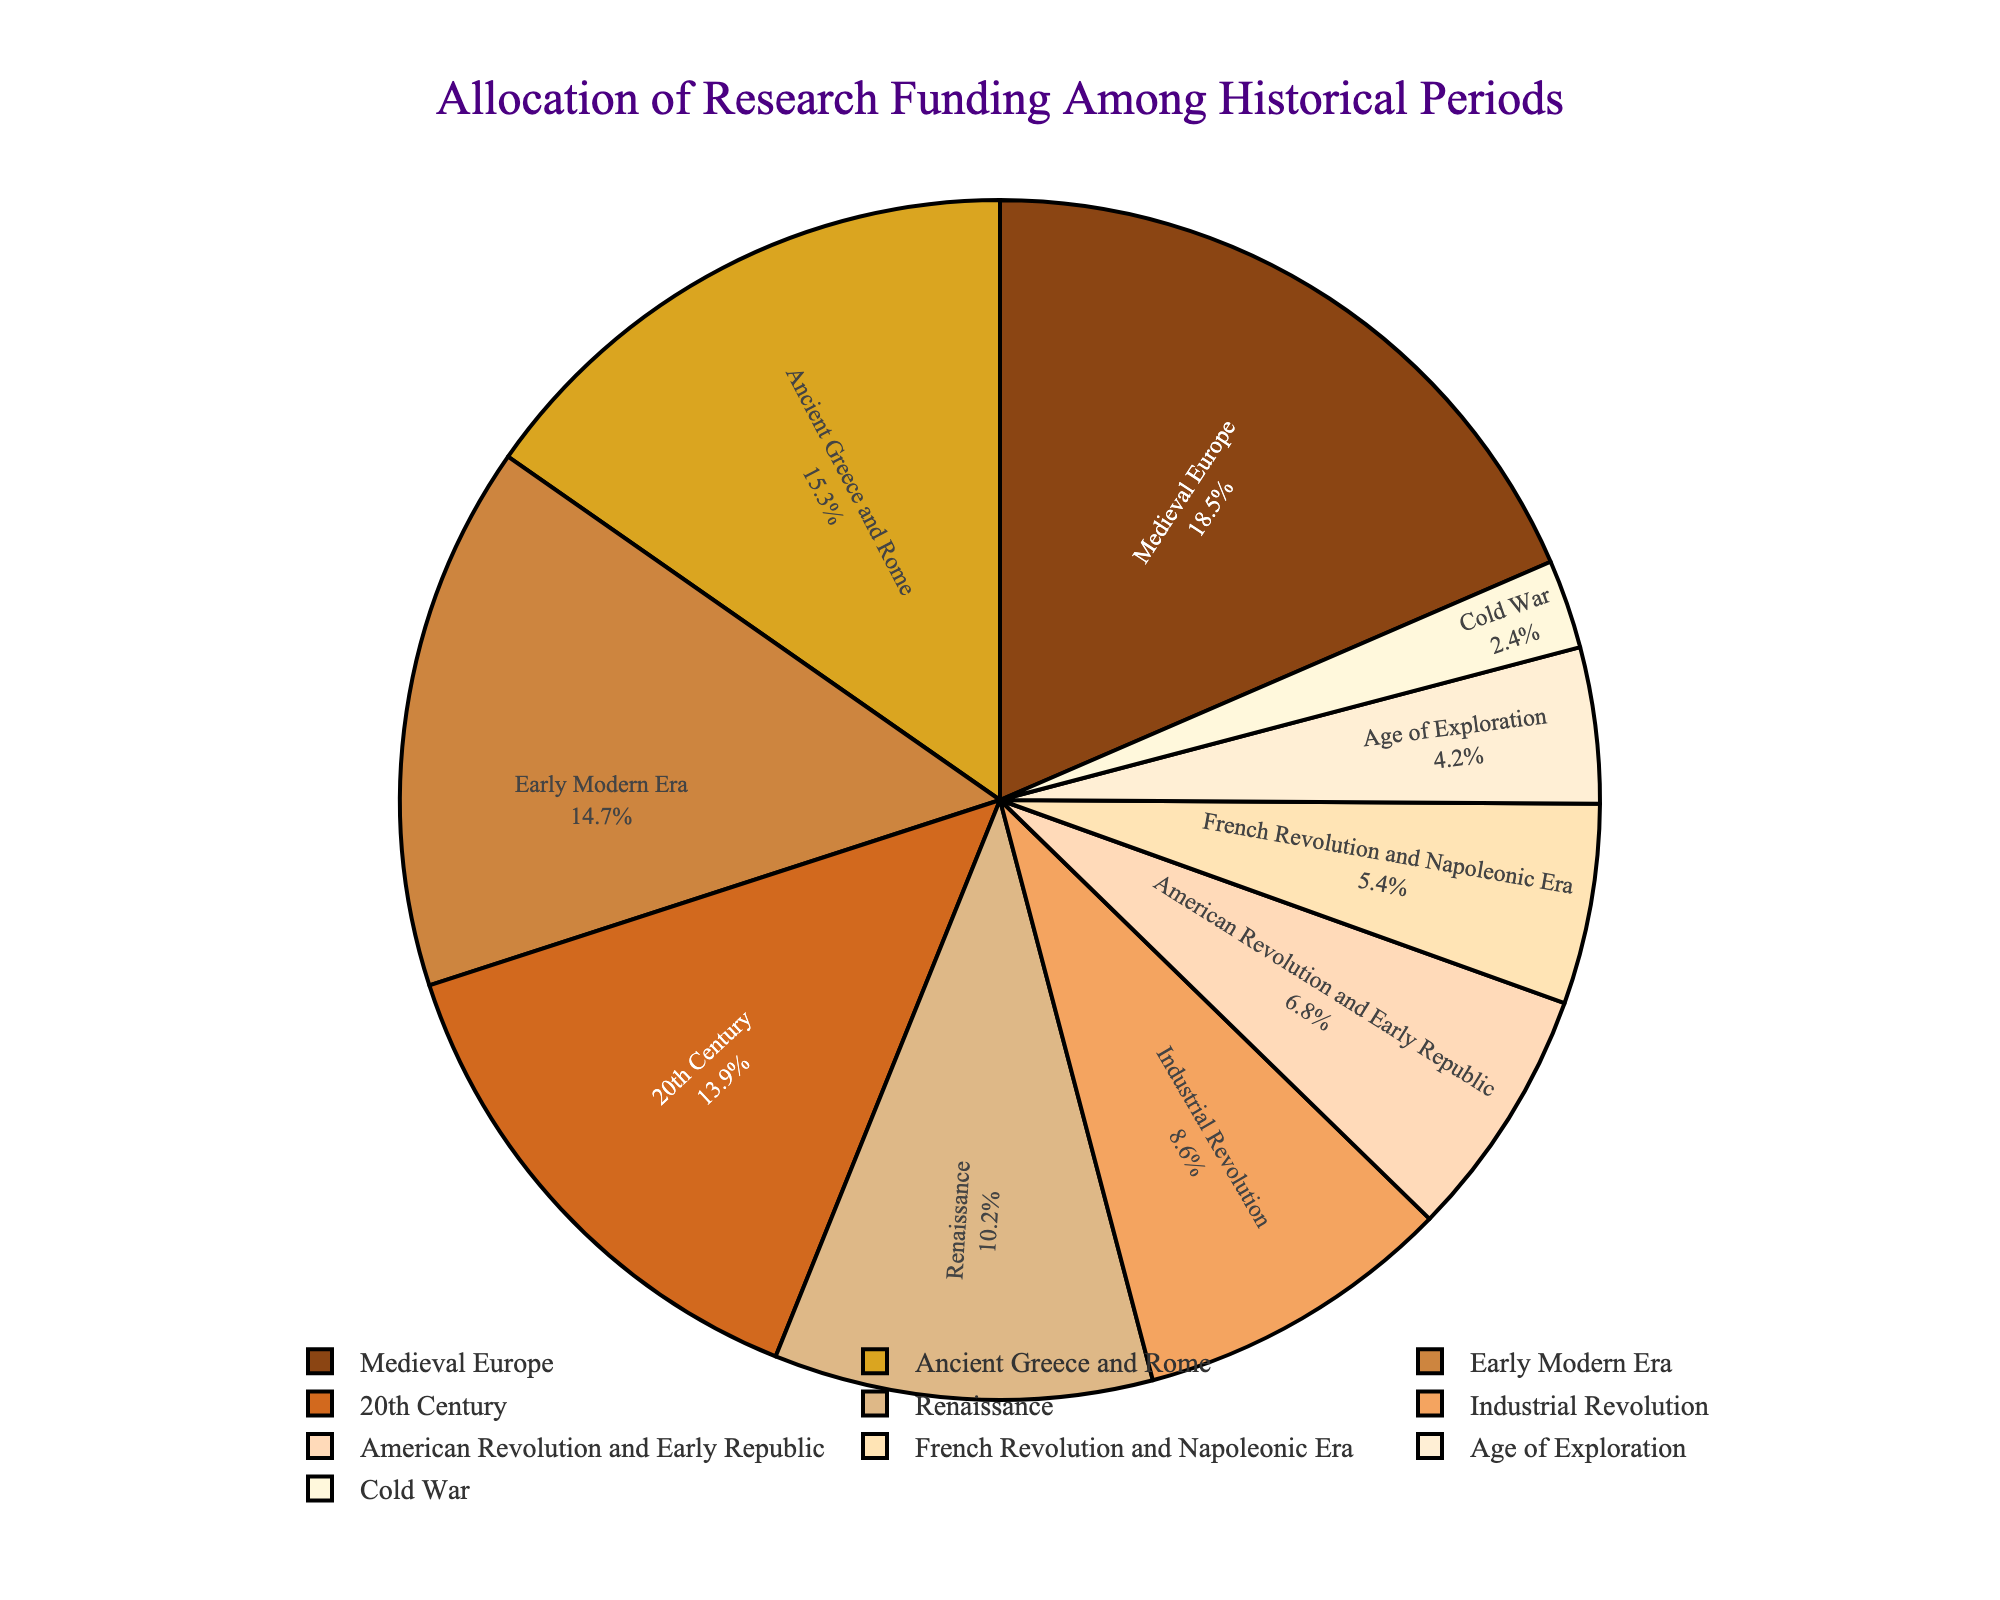). question1 explanation1
Answer: answer1 question2 explanation2
Answer: answer2 